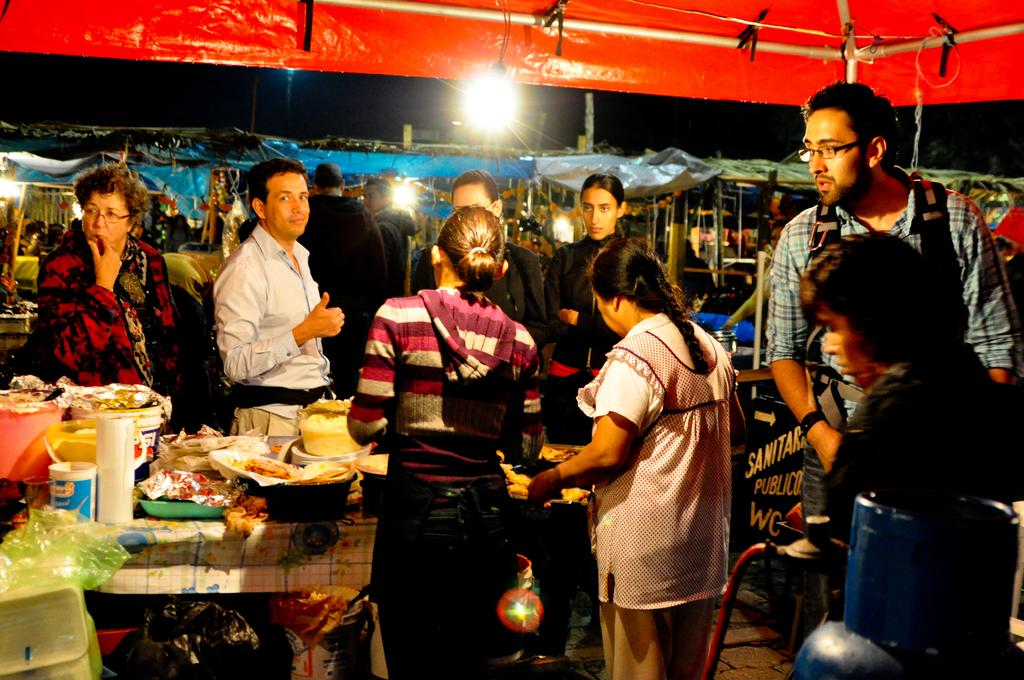How many people can be seen in the image? There are many people in the image. What structures are present in the image? There are tents in the image. What can be used for illumination in the image? There are lights in the image. What is on the table in the image? There is a table with many items in the image. How many persons are wearing specs in the image? Two persons are wearing specs. What type of items are present in the image? There are packets in the image. Where is the basket located in the image? There is no basket present in the image. What type of machine can be seen operating in the image? There is no machine present in the image. 